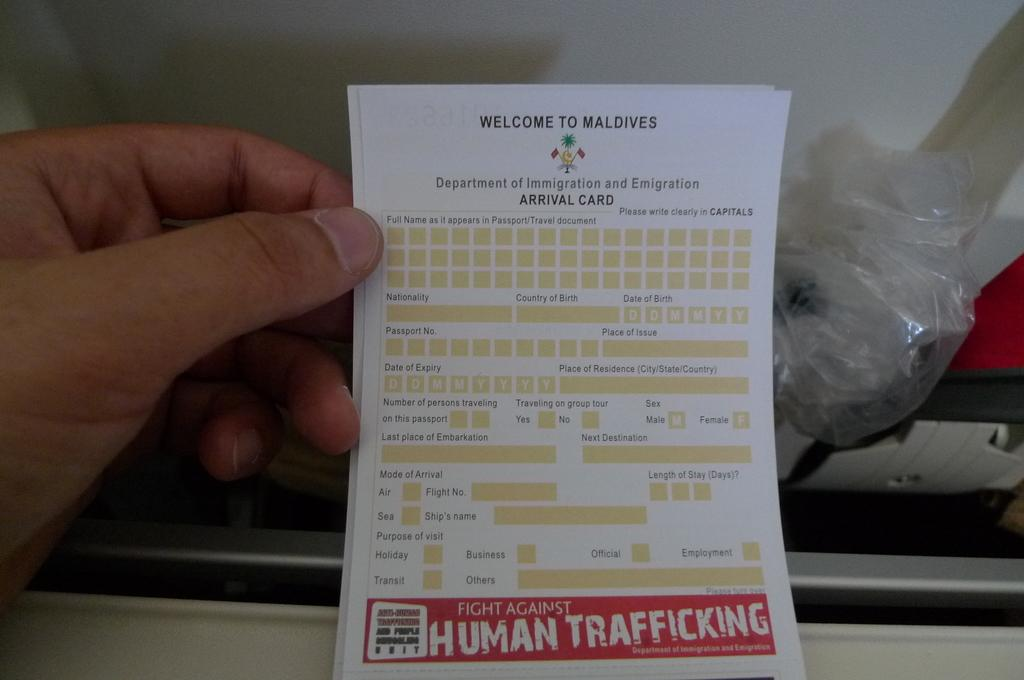What is the person holding in the image? There is a hand holding a white paper in the image. What can be seen on the paper? Something is written on the paper. What else can be observed in the image besides the paper? There are background elements visible in the image. How many apples are on the badge in the image? There is no badge or apples present in the image. 